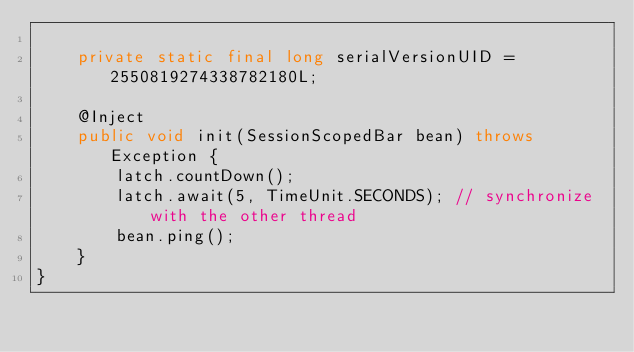<code> <loc_0><loc_0><loc_500><loc_500><_Java_>
    private static final long serialVersionUID = 2550819274338782180L;

    @Inject
    public void init(SessionScopedBar bean) throws Exception {
        latch.countDown();
        latch.await(5, TimeUnit.SECONDS); // synchronize with the other thread
        bean.ping();
    }
}
</code> 